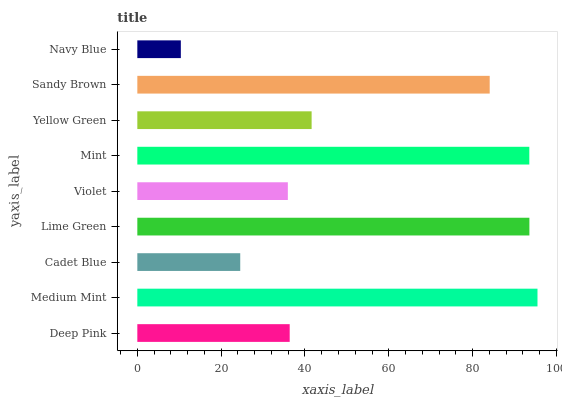Is Navy Blue the minimum?
Answer yes or no. Yes. Is Medium Mint the maximum?
Answer yes or no. Yes. Is Cadet Blue the minimum?
Answer yes or no. No. Is Cadet Blue the maximum?
Answer yes or no. No. Is Medium Mint greater than Cadet Blue?
Answer yes or no. Yes. Is Cadet Blue less than Medium Mint?
Answer yes or no. Yes. Is Cadet Blue greater than Medium Mint?
Answer yes or no. No. Is Medium Mint less than Cadet Blue?
Answer yes or no. No. Is Yellow Green the high median?
Answer yes or no. Yes. Is Yellow Green the low median?
Answer yes or no. Yes. Is Mint the high median?
Answer yes or no. No. Is Cadet Blue the low median?
Answer yes or no. No. 